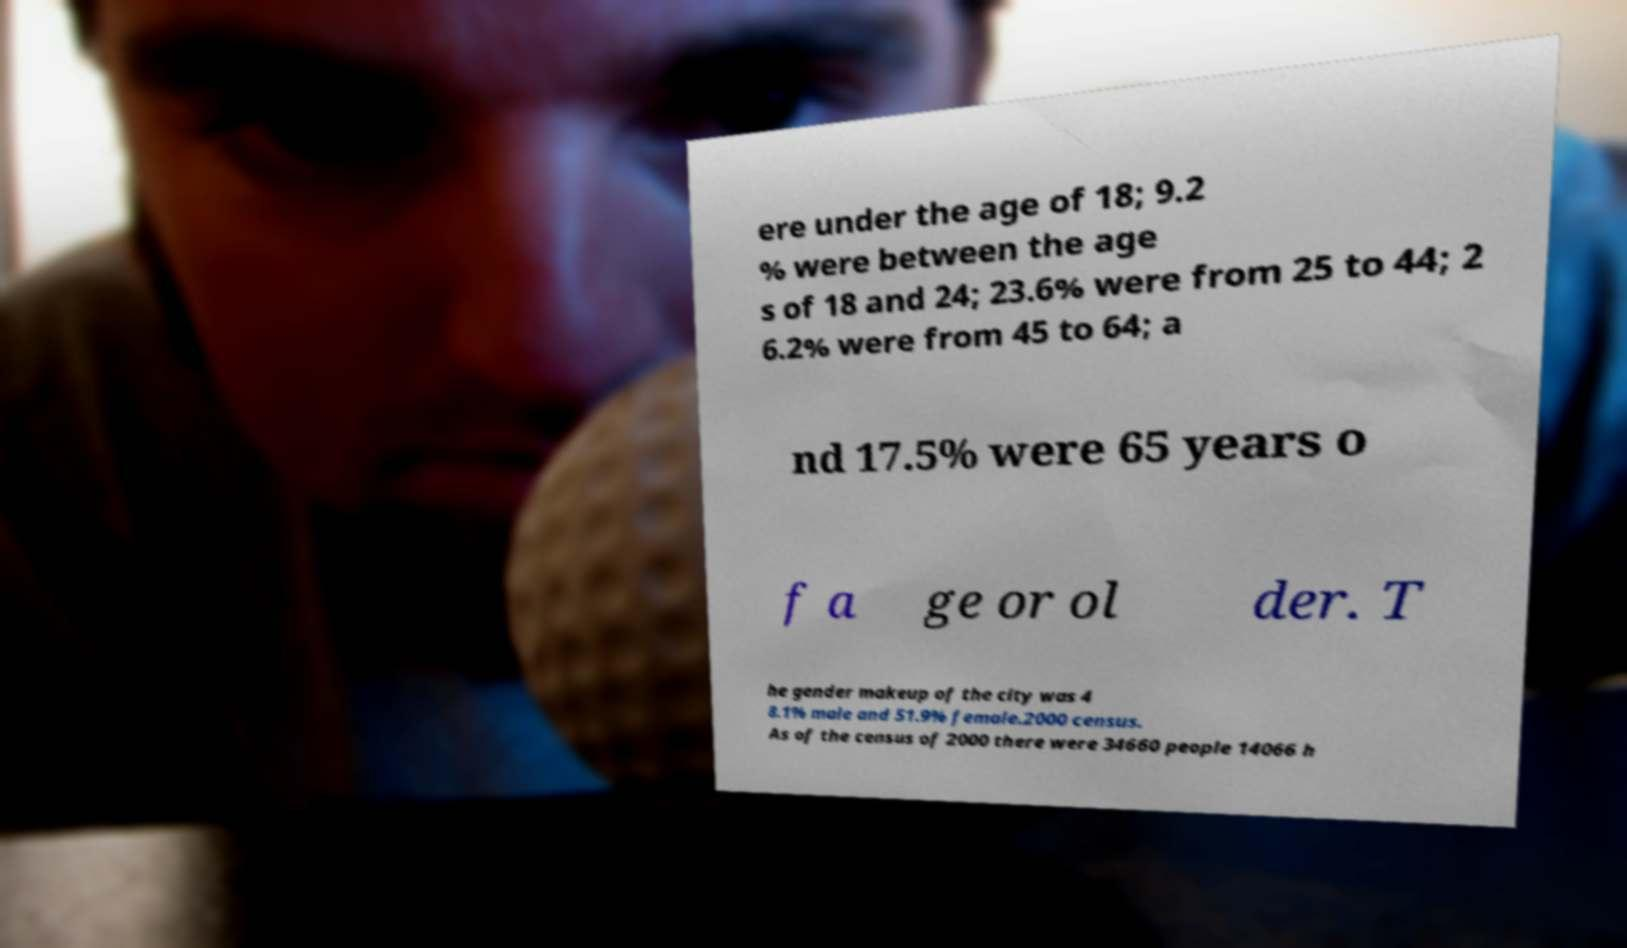Could you extract and type out the text from this image? ere under the age of 18; 9.2 % were between the age s of 18 and 24; 23.6% were from 25 to 44; 2 6.2% were from 45 to 64; a nd 17.5% were 65 years o f a ge or ol der. T he gender makeup of the city was 4 8.1% male and 51.9% female.2000 census. As of the census of 2000 there were 34660 people 14066 h 